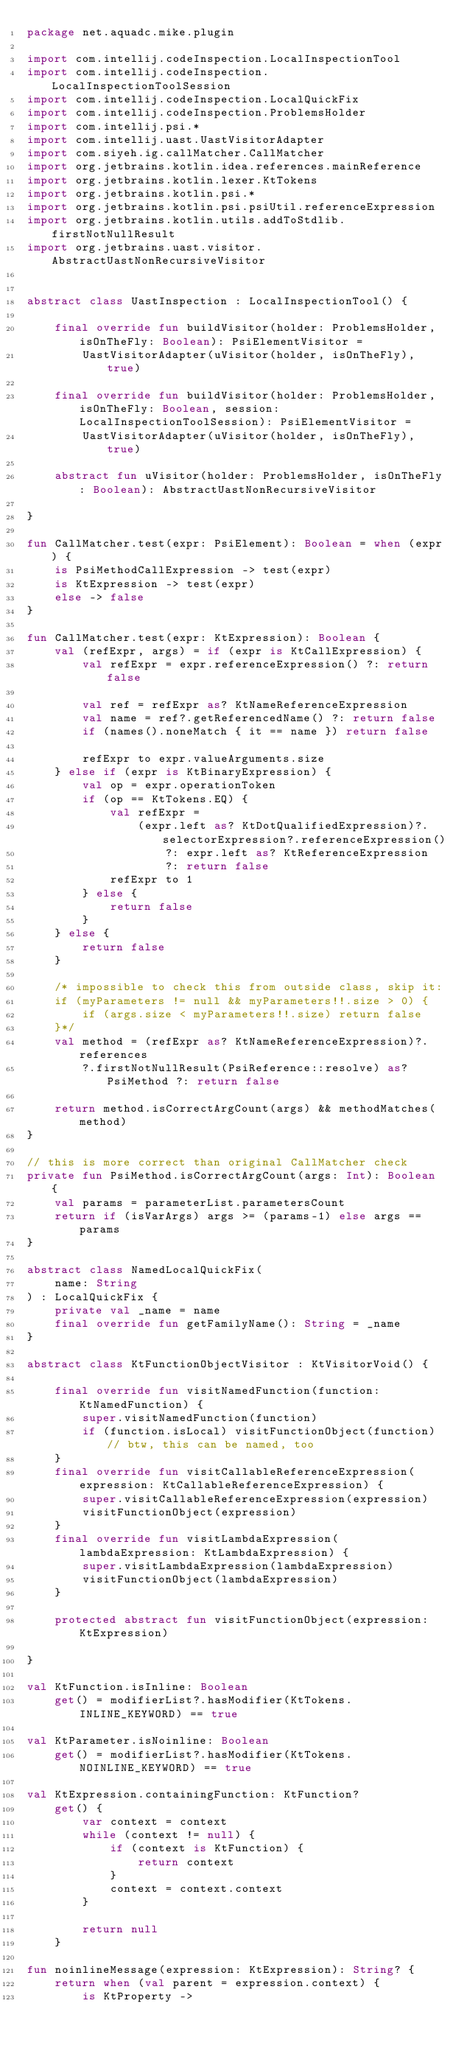<code> <loc_0><loc_0><loc_500><loc_500><_Kotlin_>package net.aquadc.mike.plugin

import com.intellij.codeInspection.LocalInspectionTool
import com.intellij.codeInspection.LocalInspectionToolSession
import com.intellij.codeInspection.LocalQuickFix
import com.intellij.codeInspection.ProblemsHolder
import com.intellij.psi.*
import com.intellij.uast.UastVisitorAdapter
import com.siyeh.ig.callMatcher.CallMatcher
import org.jetbrains.kotlin.idea.references.mainReference
import org.jetbrains.kotlin.lexer.KtTokens
import org.jetbrains.kotlin.psi.*
import org.jetbrains.kotlin.psi.psiUtil.referenceExpression
import org.jetbrains.kotlin.utils.addToStdlib.firstNotNullResult
import org.jetbrains.uast.visitor.AbstractUastNonRecursiveVisitor


abstract class UastInspection : LocalInspectionTool() {

    final override fun buildVisitor(holder: ProblemsHolder, isOnTheFly: Boolean): PsiElementVisitor =
        UastVisitorAdapter(uVisitor(holder, isOnTheFly), true)

    final override fun buildVisitor(holder: ProblemsHolder, isOnTheFly: Boolean, session: LocalInspectionToolSession): PsiElementVisitor =
        UastVisitorAdapter(uVisitor(holder, isOnTheFly), true)

    abstract fun uVisitor(holder: ProblemsHolder, isOnTheFly: Boolean): AbstractUastNonRecursiveVisitor

}

fun CallMatcher.test(expr: PsiElement): Boolean = when (expr) {
    is PsiMethodCallExpression -> test(expr)
    is KtExpression -> test(expr)
    else -> false
}

fun CallMatcher.test(expr: KtExpression): Boolean {
    val (refExpr, args) = if (expr is KtCallExpression) {
        val refExpr = expr.referenceExpression() ?: return false

        val ref = refExpr as? KtNameReferenceExpression
        val name = ref?.getReferencedName() ?: return false
        if (names().noneMatch { it == name }) return false

        refExpr to expr.valueArguments.size
    } else if (expr is KtBinaryExpression) {
        val op = expr.operationToken
        if (op == KtTokens.EQ) {
            val refExpr =
                (expr.left as? KtDotQualifiedExpression)?.selectorExpression?.referenceExpression()
                    ?: expr.left as? KtReferenceExpression
                    ?: return false
            refExpr to 1
        } else {
            return false
        }
    } else {
        return false
    }

    /* impossible to check this from outside class, skip it:
    if (myParameters != null && myParameters!!.size > 0) {
        if (args.size < myParameters!!.size) return false
    }*/
    val method = (refExpr as? KtNameReferenceExpression)?.references
        ?.firstNotNullResult(PsiReference::resolve) as? PsiMethod ?: return false

    return method.isCorrectArgCount(args) && methodMatches(method)
}

// this is more correct than original CallMatcher check
private fun PsiMethod.isCorrectArgCount(args: Int): Boolean {
    val params = parameterList.parametersCount
    return if (isVarArgs) args >= (params-1) else args == params
}

abstract class NamedLocalQuickFix(
    name: String
) : LocalQuickFix {
    private val _name = name
    final override fun getFamilyName(): String = _name
}

abstract class KtFunctionObjectVisitor : KtVisitorVoid() {

    final override fun visitNamedFunction(function: KtNamedFunction) {
        super.visitNamedFunction(function)
        if (function.isLocal) visitFunctionObject(function) // btw, this can be named, too
    }
    final override fun visitCallableReferenceExpression(expression: KtCallableReferenceExpression) {
        super.visitCallableReferenceExpression(expression)
        visitFunctionObject(expression)
    }
    final override fun visitLambdaExpression(lambdaExpression: KtLambdaExpression) {
        super.visitLambdaExpression(lambdaExpression)
        visitFunctionObject(lambdaExpression)
    }

    protected abstract fun visitFunctionObject(expression: KtExpression)

}

val KtFunction.isInline: Boolean
    get() = modifierList?.hasModifier(KtTokens.INLINE_KEYWORD) == true

val KtParameter.isNoinline: Boolean
    get() = modifierList?.hasModifier(KtTokens.NOINLINE_KEYWORD) == true

val KtExpression.containingFunction: KtFunction?
    get() {
        var context = context
        while (context != null) {
            if (context is KtFunction) {
                return context
            }
            context = context.context
        }

        return null
    }

fun noinlineMessage(expression: KtExpression): String? {
    return when (val parent = expression.context) {
        is KtProperty -></code> 